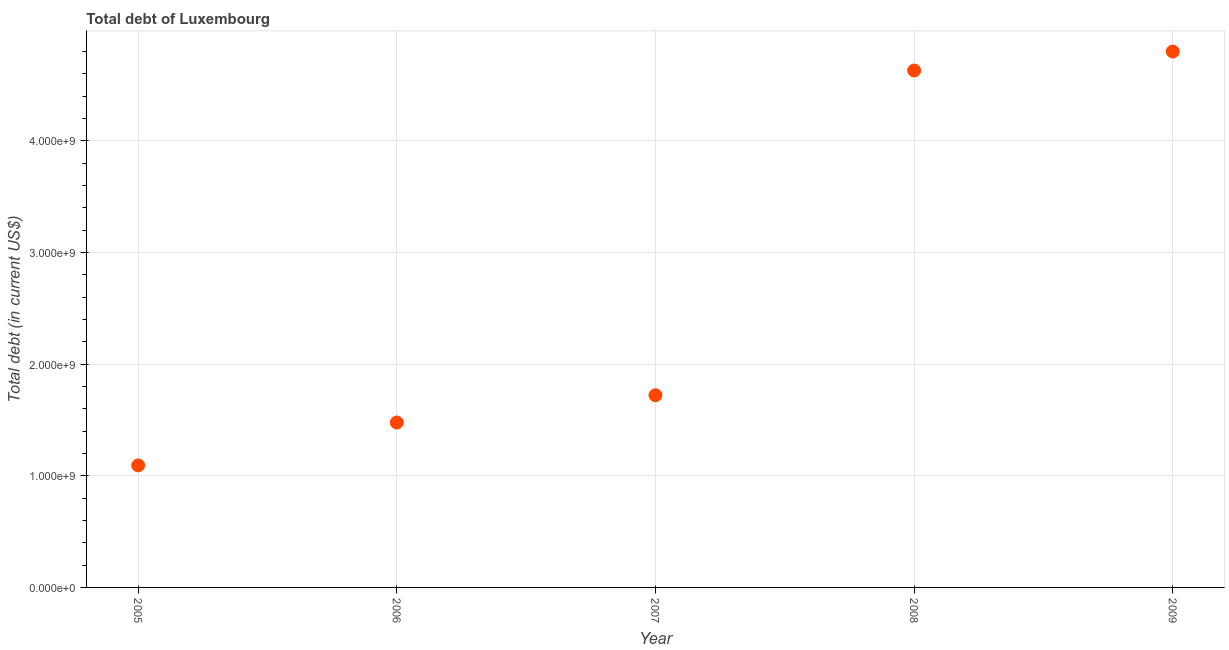What is the total debt in 2005?
Ensure brevity in your answer.  1.09e+09. Across all years, what is the maximum total debt?
Keep it short and to the point. 4.80e+09. Across all years, what is the minimum total debt?
Make the answer very short. 1.09e+09. In which year was the total debt maximum?
Make the answer very short. 2009. What is the sum of the total debt?
Keep it short and to the point. 1.37e+1. What is the difference between the total debt in 2008 and 2009?
Provide a short and direct response. -1.70e+08. What is the average total debt per year?
Your response must be concise. 2.74e+09. What is the median total debt?
Your answer should be very brief. 1.72e+09. In how many years, is the total debt greater than 3600000000 US$?
Provide a short and direct response. 2. Do a majority of the years between 2009 and 2005 (inclusive) have total debt greater than 1400000000 US$?
Your response must be concise. Yes. What is the ratio of the total debt in 2007 to that in 2009?
Your answer should be compact. 0.36. Is the difference between the total debt in 2006 and 2008 greater than the difference between any two years?
Offer a terse response. No. What is the difference between the highest and the second highest total debt?
Your response must be concise. 1.70e+08. Is the sum of the total debt in 2007 and 2008 greater than the maximum total debt across all years?
Your response must be concise. Yes. What is the difference between the highest and the lowest total debt?
Your response must be concise. 3.71e+09. In how many years, is the total debt greater than the average total debt taken over all years?
Ensure brevity in your answer.  2. Does the total debt monotonically increase over the years?
Your answer should be compact. Yes. How many years are there in the graph?
Your answer should be compact. 5. Does the graph contain grids?
Provide a succinct answer. Yes. What is the title of the graph?
Provide a succinct answer. Total debt of Luxembourg. What is the label or title of the Y-axis?
Offer a very short reply. Total debt (in current US$). What is the Total debt (in current US$) in 2005?
Make the answer very short. 1.09e+09. What is the Total debt (in current US$) in 2006?
Keep it short and to the point. 1.48e+09. What is the Total debt (in current US$) in 2007?
Provide a short and direct response. 1.72e+09. What is the Total debt (in current US$) in 2008?
Your response must be concise. 4.63e+09. What is the Total debt (in current US$) in 2009?
Your answer should be compact. 4.80e+09. What is the difference between the Total debt (in current US$) in 2005 and 2006?
Give a very brief answer. -3.84e+08. What is the difference between the Total debt (in current US$) in 2005 and 2007?
Your response must be concise. -6.28e+08. What is the difference between the Total debt (in current US$) in 2005 and 2008?
Your response must be concise. -3.54e+09. What is the difference between the Total debt (in current US$) in 2005 and 2009?
Offer a very short reply. -3.71e+09. What is the difference between the Total debt (in current US$) in 2006 and 2007?
Provide a short and direct response. -2.44e+08. What is the difference between the Total debt (in current US$) in 2006 and 2008?
Give a very brief answer. -3.15e+09. What is the difference between the Total debt (in current US$) in 2006 and 2009?
Your response must be concise. -3.32e+09. What is the difference between the Total debt (in current US$) in 2007 and 2008?
Make the answer very short. -2.91e+09. What is the difference between the Total debt (in current US$) in 2007 and 2009?
Keep it short and to the point. -3.08e+09. What is the difference between the Total debt (in current US$) in 2008 and 2009?
Provide a succinct answer. -1.70e+08. What is the ratio of the Total debt (in current US$) in 2005 to that in 2006?
Keep it short and to the point. 0.74. What is the ratio of the Total debt (in current US$) in 2005 to that in 2007?
Provide a succinct answer. 0.64. What is the ratio of the Total debt (in current US$) in 2005 to that in 2008?
Make the answer very short. 0.24. What is the ratio of the Total debt (in current US$) in 2005 to that in 2009?
Ensure brevity in your answer.  0.23. What is the ratio of the Total debt (in current US$) in 2006 to that in 2007?
Your response must be concise. 0.86. What is the ratio of the Total debt (in current US$) in 2006 to that in 2008?
Your response must be concise. 0.32. What is the ratio of the Total debt (in current US$) in 2006 to that in 2009?
Ensure brevity in your answer.  0.31. What is the ratio of the Total debt (in current US$) in 2007 to that in 2008?
Your response must be concise. 0.37. What is the ratio of the Total debt (in current US$) in 2007 to that in 2009?
Your answer should be compact. 0.36. 